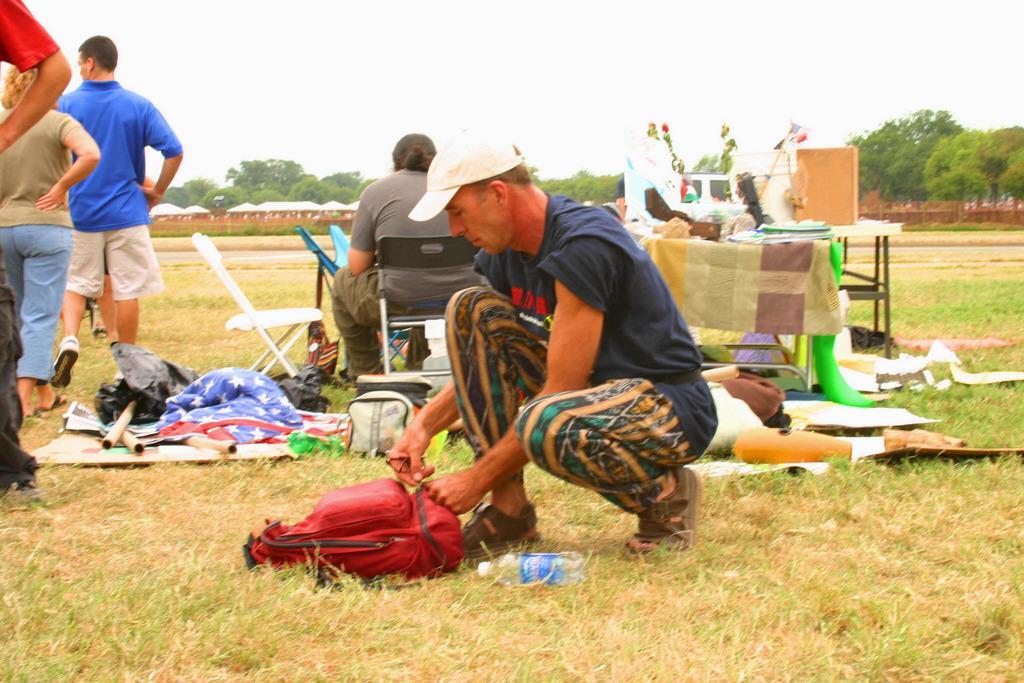Can you describe this image briefly? In this image we can see one big ground, some green grass, so many trees, so many people, some people are standing, one person sitting on a chair and one man in crouch position, holding a bag. There are some tables, so many different objects are on the table, so many different objects on the surface and at the top there is the sky. 